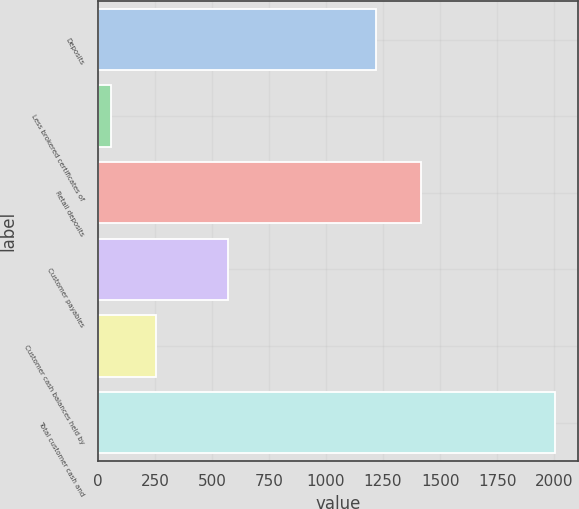<chart> <loc_0><loc_0><loc_500><loc_500><bar_chart><fcel>Deposits<fcel>Less brokered certificates of<fcel>Retail deposits<fcel>Customer payables<fcel>Customer cash balances held by<fcel>Total customer cash and<nl><fcel>1219.7<fcel>58.3<fcel>1414.38<fcel>570.8<fcel>252.98<fcel>2005.1<nl></chart> 